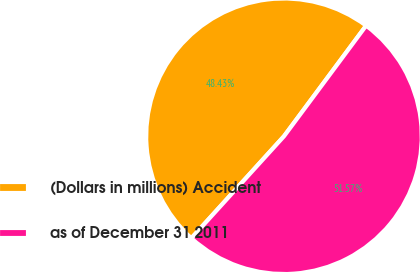Convert chart to OTSL. <chart><loc_0><loc_0><loc_500><loc_500><pie_chart><fcel>(Dollars in millions) Accident<fcel>as of December 31 2011<nl><fcel>48.43%<fcel>51.57%<nl></chart> 